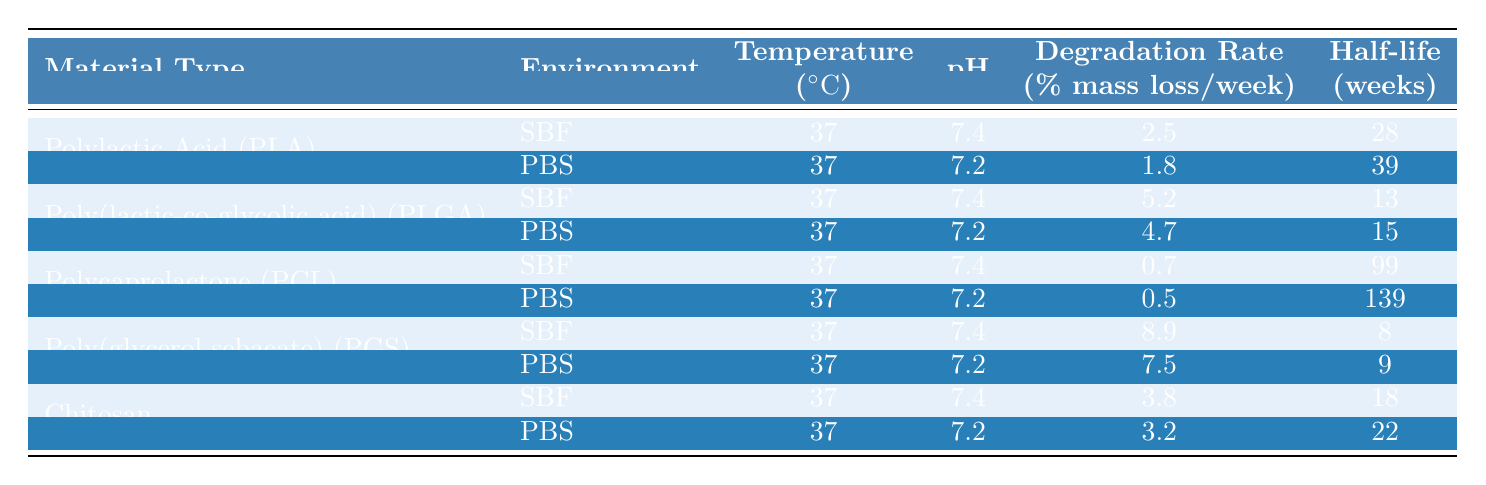What is the degradation rate of Poly(lactic-co-glycolic acid) (PLGA) in Phosphate Buffered Saline (PBS)? According to the table, the degradation rate of PLGA in PBS is specifically mentioned as 4.7% mass loss per week.
Answer: 4.7% Which material has the highest degradation rate in Simulated Body Fluid (SBF)? The table shows that Poly(glycerol sebacate) (PGS) has the highest degradation rate in SBF at 8.9% mass loss per week, which is greater than the rates of all other materials listed under the same environment.
Answer: Poly(glycerol sebacate) (PGS) What is the half-life of Chitosan in Phosphate Buffered Saline (PBS)? The table indicates that the half-life of Chitosan in PBS is 22 weeks, clearly stated next to the degradation rate information for this environment.
Answer: 22 weeks Is the degradation rate of Polycaprolactone (PCL) higher in Simulated Body Fluid (SBF) or Phosphate Buffered Saline (PBS)? In SBF, PCL has a degradation rate of 0.7% mass loss per week, while in PBS it is 0.5%. Since 0.7% is greater than 0.5%, the degradation rate in SBF is higher.
Answer: In Simulated Body Fluid (SBF) Calculate the average degradation rate across all materials in Simulated Body Fluid (SBF). The degradation rates in SBF are: 2.5% (PLA), 5.2% (PLGA), 0.7% (PCL), 8.9% (PGS), and 3.8% (Chitosan). Adding these gives 2.5 + 5.2 + 0.7 + 8.9 + 3.8 = 21.1%. Dividing by 5 (the number of materials) gives an average of 21.1 / 5 = 4.22%.
Answer: 4.22% What material has the longest half-life in the table? Looking at the half-life data, Polycaprolactone (PCL) in PBS has the longest half-life of 139 weeks. This is longer than the half-lives of all other materials listed in the table.
Answer: Polycaprolactone (PCL) Does any material have the same degradation rate in both environments? By examining the degradation rates listed for each material in both SBF and PBS, it’s evident that none of the materials have identical degradation rates in both environments; all values differ.
Answer: No What is the difference in degradation rates between PGS and PLA in Simulated Body Fluid (SBF)? In SBF, PGS has a degradation rate of 8.9% and PLA has a degradation rate of 2.5%. The difference is 8.9% - 2.5% = 6.4%.
Answer: 6.4% Which polymer has the lowest degradation rate in PBS? The table shows that Polycaprolactone (PCL) has the lowest degradation rate in PBS at 0.5% mass loss per week, which is less than the other materials in that environment.
Answer: Polycaprolactone (PCL) How does the degradation rate of Chitosan compare between PBS and SBF? In PBS, Chitosan has a degradation rate of 3.2% and in SBF it is 3.8%. Since 3.8% is higher than 3.2%, Chitosan degrades faster in SBF than in PBS.
Answer: Faster in SBF 